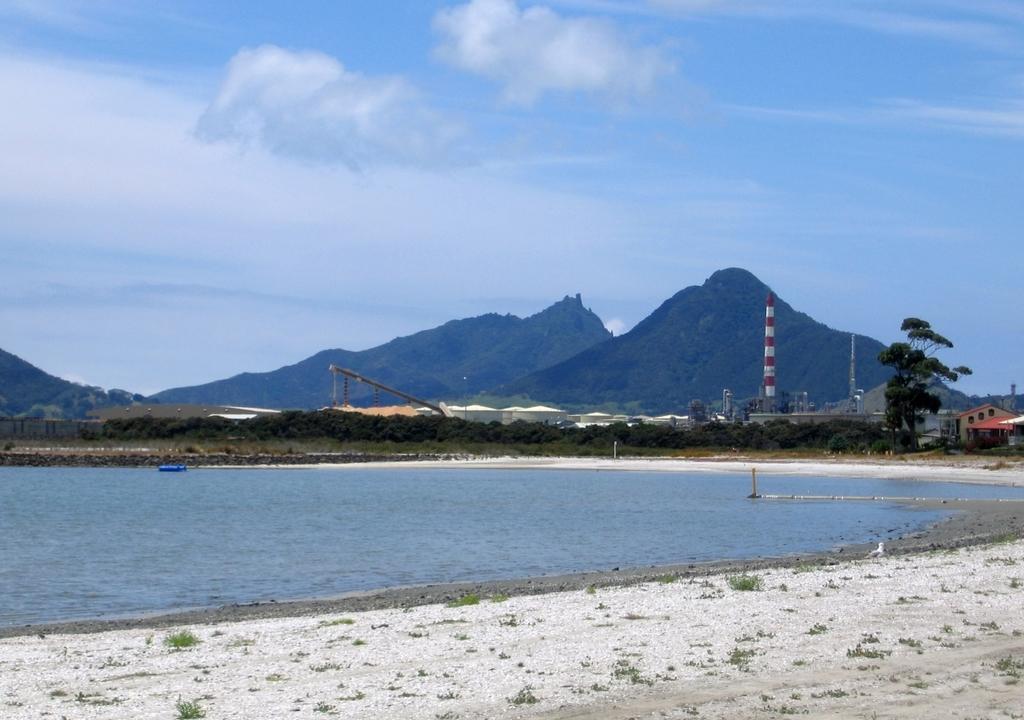Can you describe this image briefly? At the bottom of the picture, we see the small stones and sand. Beside that, we see water and this water might be in the lake. In the middle, we see the trees. On the right side, we see the buildings and trees. There are poles and towers in the background. There are trees and hills in the background. At the top, we see the sky and the clouds. 